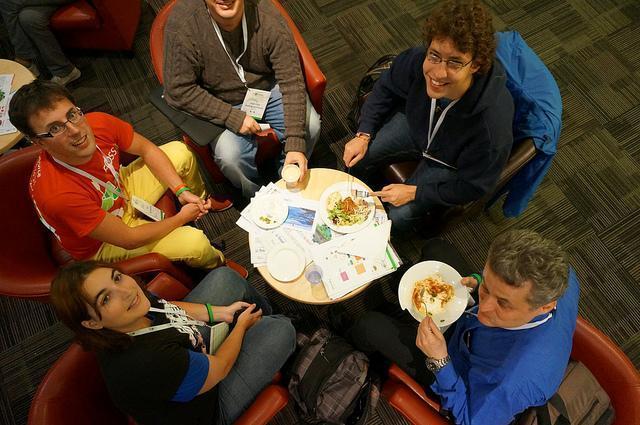How many backpacks are there?
Give a very brief answer. 2. How many chairs can be seen?
Give a very brief answer. 5. How many people are there?
Give a very brief answer. 6. 